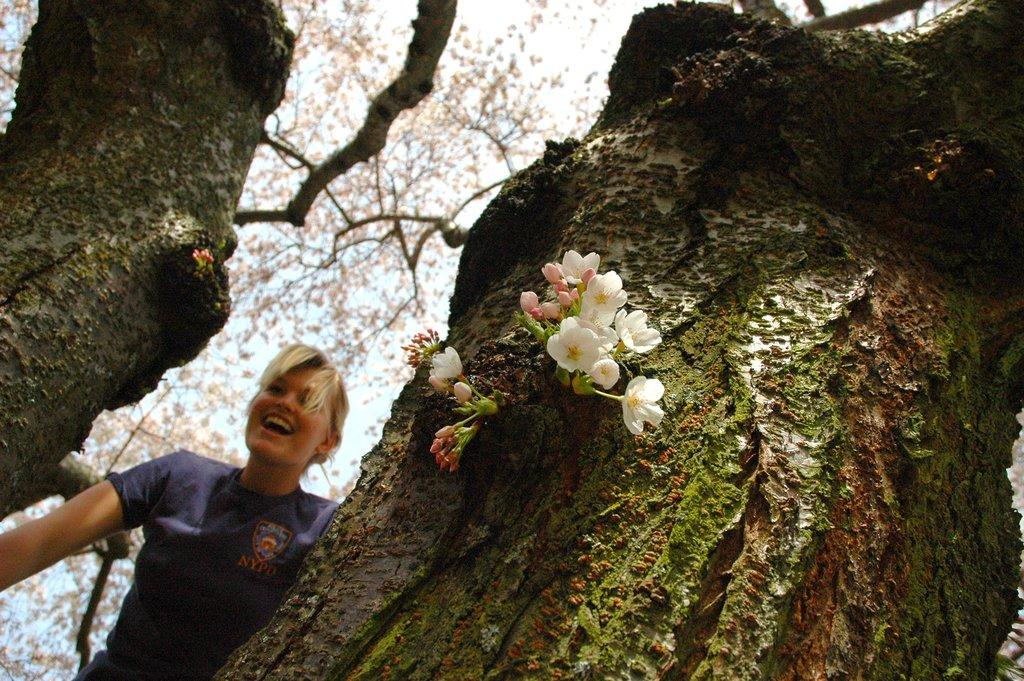What is the person in the image doing? The person is standing behind a tree in the image. What is the facial expression of the person? The person is smiling. What can be seen on the tree in the foreground? There are flowers on the tree in the foreground. What is visible at the top of the image? The sky is visible at the top of the image. What type of plot does the person have in the image? There is no mention of a plot in the image; it features a person standing behind a tree with flowers on the foreground tree and a visible sky. What kind of experience can be seen in the image? The image does not depict an experience; it shows a person standing behind a tree with flowers on the foreground tree and a visible sky. 